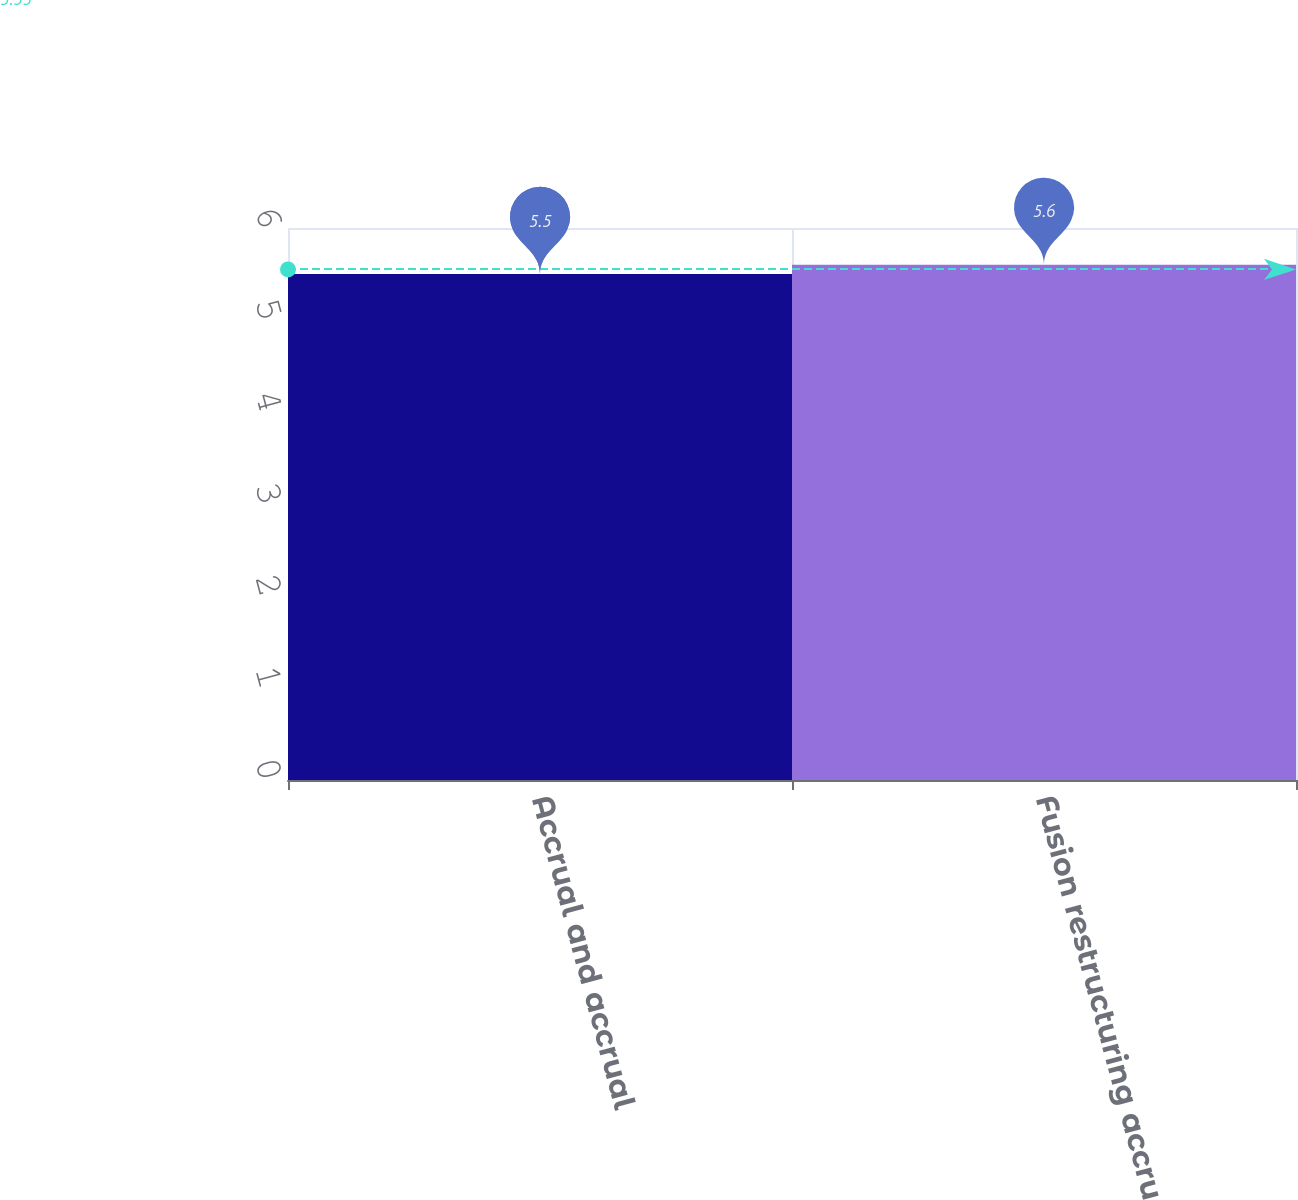Convert chart. <chart><loc_0><loc_0><loc_500><loc_500><bar_chart><fcel>Accrual and accrual<fcel>Fusion restructuring accrual<nl><fcel>5.5<fcel>5.6<nl></chart> 